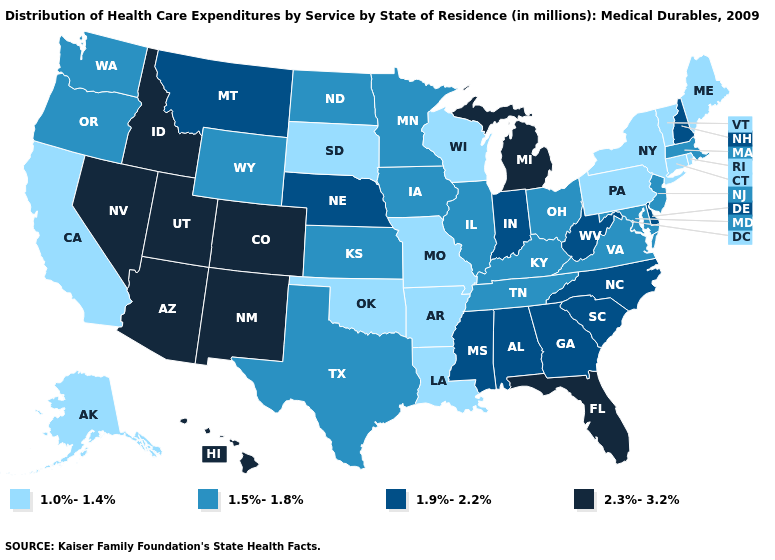Name the states that have a value in the range 1.9%-2.2%?
Write a very short answer. Alabama, Delaware, Georgia, Indiana, Mississippi, Montana, Nebraska, New Hampshire, North Carolina, South Carolina, West Virginia. Name the states that have a value in the range 1.5%-1.8%?
Be succinct. Illinois, Iowa, Kansas, Kentucky, Maryland, Massachusetts, Minnesota, New Jersey, North Dakota, Ohio, Oregon, Tennessee, Texas, Virginia, Washington, Wyoming. Does the map have missing data?
Keep it brief. No. Which states have the lowest value in the MidWest?
Write a very short answer. Missouri, South Dakota, Wisconsin. What is the lowest value in the USA?
Short answer required. 1.0%-1.4%. Name the states that have a value in the range 2.3%-3.2%?
Concise answer only. Arizona, Colorado, Florida, Hawaii, Idaho, Michigan, Nevada, New Mexico, Utah. Name the states that have a value in the range 1.0%-1.4%?
Write a very short answer. Alaska, Arkansas, California, Connecticut, Louisiana, Maine, Missouri, New York, Oklahoma, Pennsylvania, Rhode Island, South Dakota, Vermont, Wisconsin. Name the states that have a value in the range 1.0%-1.4%?
Write a very short answer. Alaska, Arkansas, California, Connecticut, Louisiana, Maine, Missouri, New York, Oklahoma, Pennsylvania, Rhode Island, South Dakota, Vermont, Wisconsin. What is the lowest value in the USA?
Quick response, please. 1.0%-1.4%. What is the value of Utah?
Quick response, please. 2.3%-3.2%. Name the states that have a value in the range 1.9%-2.2%?
Answer briefly. Alabama, Delaware, Georgia, Indiana, Mississippi, Montana, Nebraska, New Hampshire, North Carolina, South Carolina, West Virginia. What is the lowest value in the MidWest?
Be succinct. 1.0%-1.4%. What is the lowest value in states that border Ohio?
Keep it brief. 1.0%-1.4%. How many symbols are there in the legend?
Give a very brief answer. 4. Does Louisiana have the lowest value in the South?
Answer briefly. Yes. 